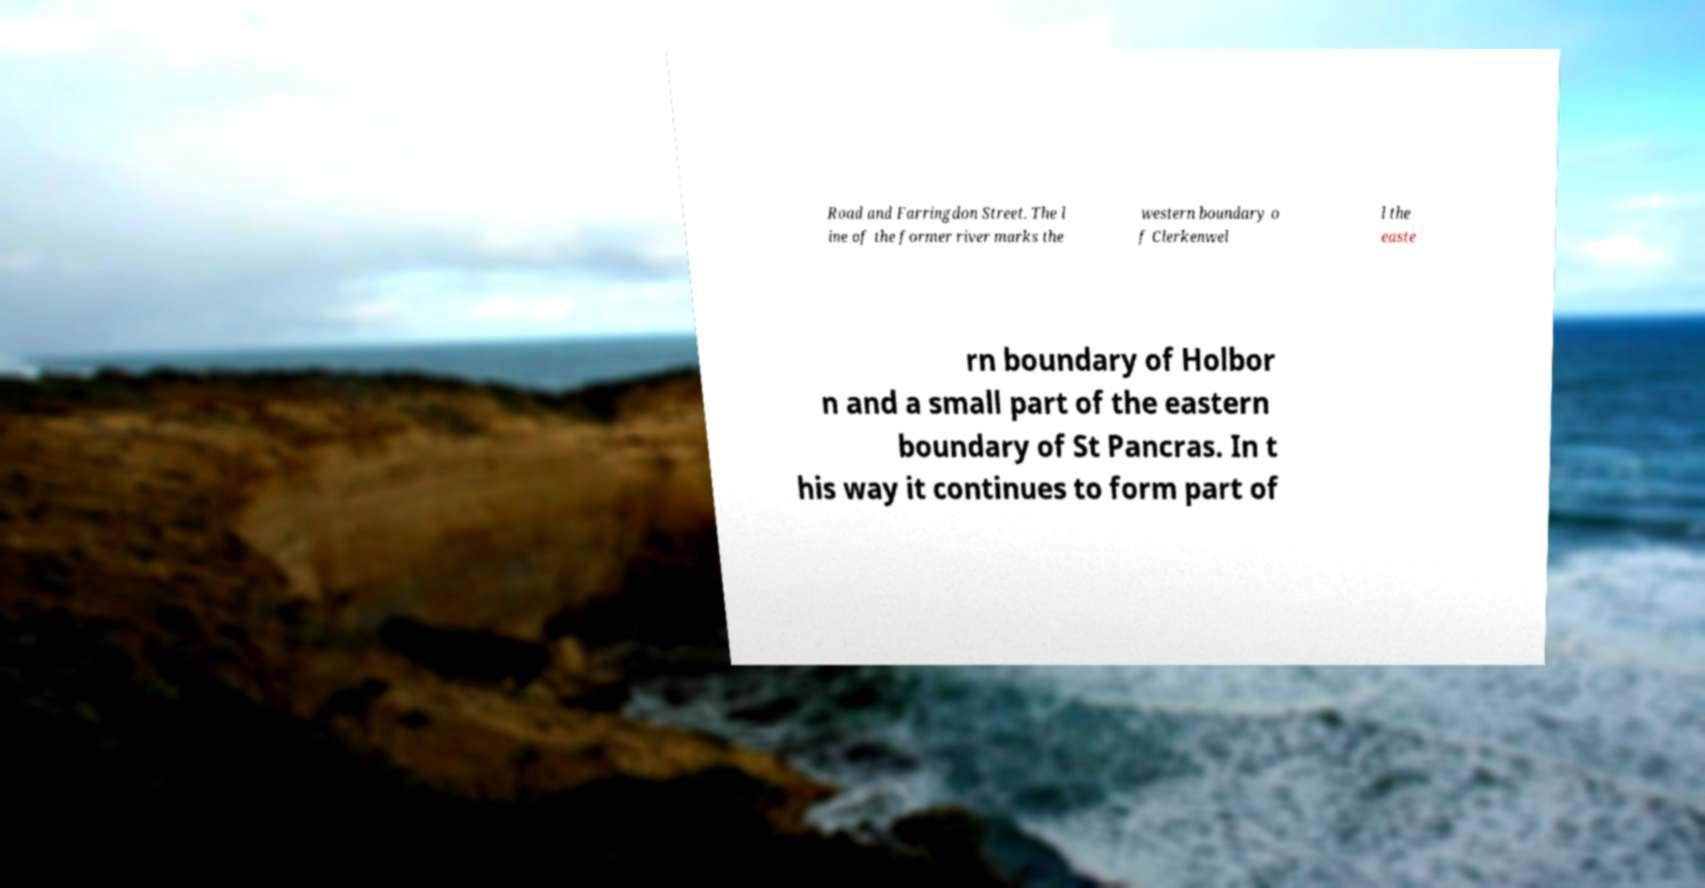There's text embedded in this image that I need extracted. Can you transcribe it verbatim? Road and Farringdon Street. The l ine of the former river marks the western boundary o f Clerkenwel l the easte rn boundary of Holbor n and a small part of the eastern boundary of St Pancras. In t his way it continues to form part of 